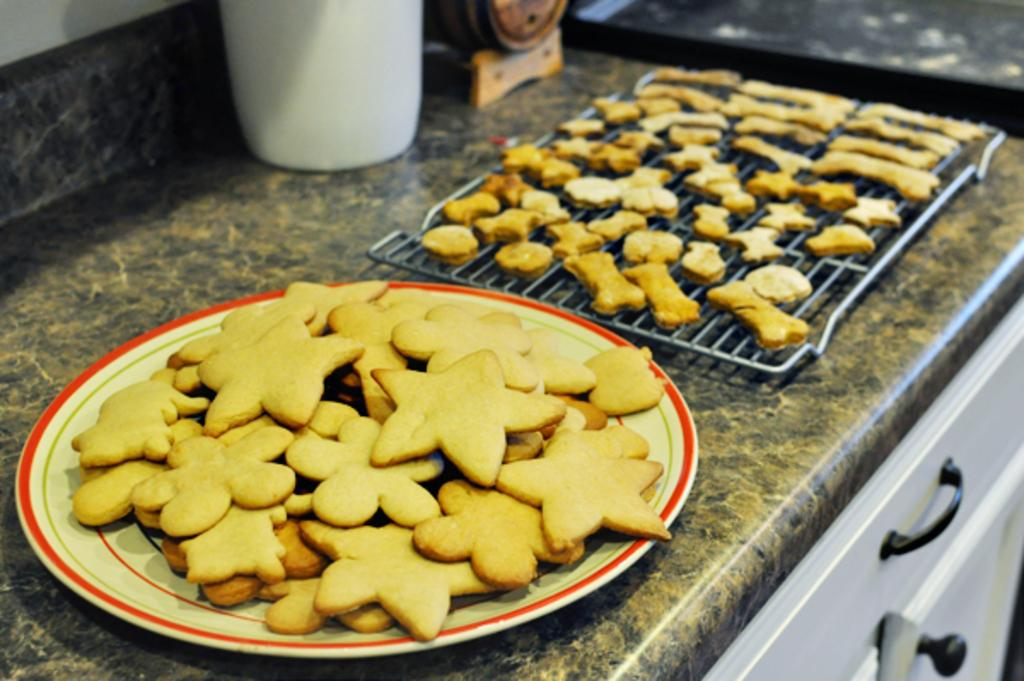What type of food is on the plate in the image? There are biscuits on a white color plate in the image. What can be seen on the right side of the image? There is a grill on the right side of the image. How many family members can be seen in the image? There are no family members visible in the image. What type of view is shown in the image? The image does not depict a view; it shows biscuits on a plate and a grill. 